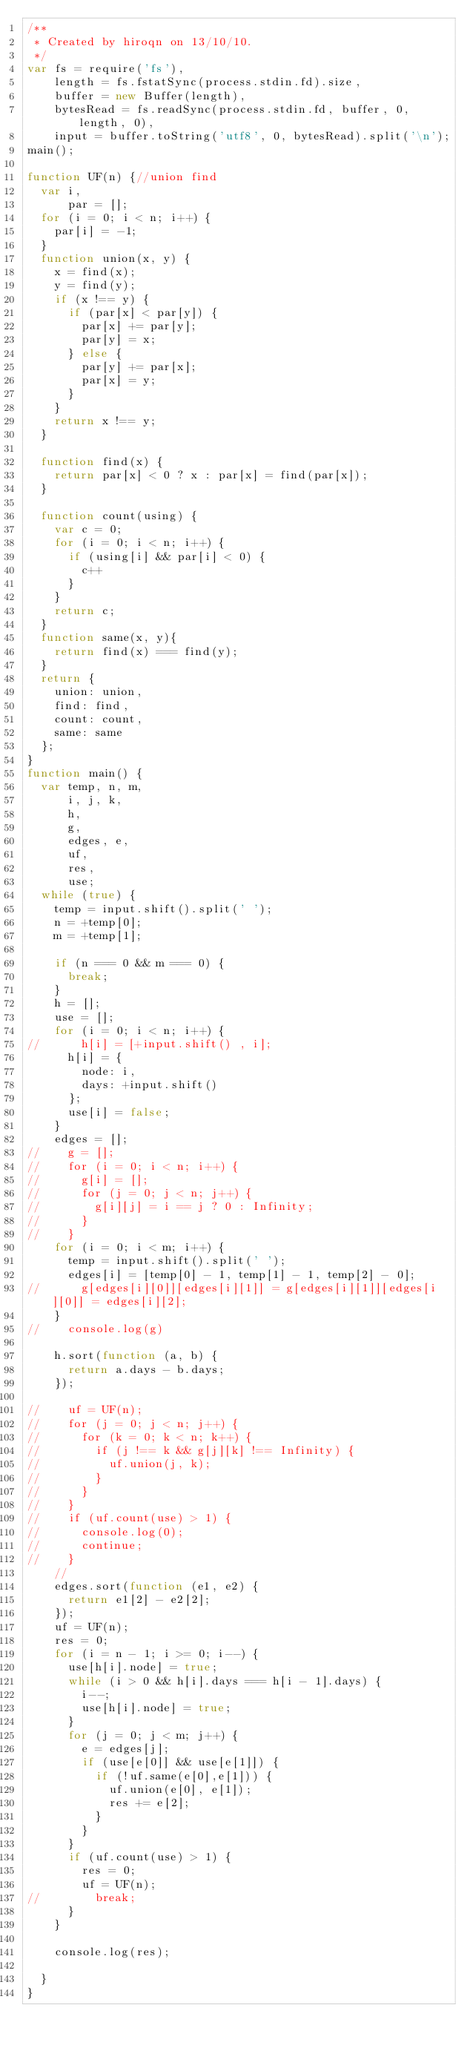Convert code to text. <code><loc_0><loc_0><loc_500><loc_500><_JavaScript_>/**
 * Created by hiroqn on 13/10/10.
 */
var fs = require('fs'),
    length = fs.fstatSync(process.stdin.fd).size,
    buffer = new Buffer(length),
    bytesRead = fs.readSync(process.stdin.fd, buffer, 0, length, 0),
    input = buffer.toString('utf8', 0, bytesRead).split('\n');
main();

function UF(n) {//union find
  var i,
      par = [];
  for (i = 0; i < n; i++) {
    par[i] = -1;
  }
  function union(x, y) {
    x = find(x);
    y = find(y);
    if (x !== y) {
      if (par[x] < par[y]) {
        par[x] += par[y];
        par[y] = x;
      } else {
        par[y] += par[x];
        par[x] = y;
      }
    }
    return x !== y;
  }

  function find(x) {
    return par[x] < 0 ? x : par[x] = find(par[x]);
  }

  function count(using) {
    var c = 0;
    for (i = 0; i < n; i++) {
      if (using[i] && par[i] < 0) {
        c++
      }
    }
    return c;
  }
  function same(x, y){
    return find(x) === find(y);
  }
  return {
    union: union,
    find: find,
    count: count,
    same: same
  };
}
function main() {
  var temp, n, m,
      i, j, k,
      h,
      g,
      edges, e,
      uf,
      res,
      use;
  while (true) {
    temp = input.shift().split(' ');
    n = +temp[0];
    m = +temp[1];

    if (n === 0 && m === 0) {
      break;
    }
    h = [];
    use = [];
    for (i = 0; i < n; i++) {
//      h[i] = [+input.shift() , i];
      h[i] = {
        node: i,
        days: +input.shift()
      };
      use[i] = false;
    }
    edges = [];
//    g = [];
//    for (i = 0; i < n; i++) {
//      g[i] = [];
//      for (j = 0; j < n; j++) {
//        g[i][j] = i == j ? 0 : Infinity;
//      }
//    }
    for (i = 0; i < m; i++) {
      temp = input.shift().split(' ');
      edges[i] = [temp[0] - 1, temp[1] - 1, temp[2] - 0];
//      g[edges[i][0]][edges[i][1]] = g[edges[i][1]][edges[i][0]] = edges[i][2];
    }
//    console.log(g)

    h.sort(function (a, b) {
      return a.days - b.days;
    });

//    uf = UF(n);
//    for (j = 0; j < n; j++) {
//      for (k = 0; k < n; k++) {
//        if (j !== k && g[j][k] !== Infinity) {
//          uf.union(j, k);
//        }
//      }
//    }
//    if (uf.count(use) > 1) {
//      console.log(0);
//      continue;
//    }
    //
    edges.sort(function (e1, e2) {
      return e1[2] - e2[2];
    });
    uf = UF(n);
    res = 0;
    for (i = n - 1; i >= 0; i--) {
      use[h[i].node] = true;
      while (i > 0 && h[i].days === h[i - 1].days) {
        i--;
        use[h[i].node] = true;
      }
      for (j = 0; j < m; j++) {
        e = edges[j];
        if (use[e[0]] && use[e[1]]) {
          if (!uf.same(e[0],e[1])) {
            uf.union(e[0], e[1]);
            res += e[2];
          }
        }
      }
      if (uf.count(use) > 1) {
        res = 0;
        uf = UF(n);
//        break;
      }
    }

    console.log(res);

  }
}</code> 